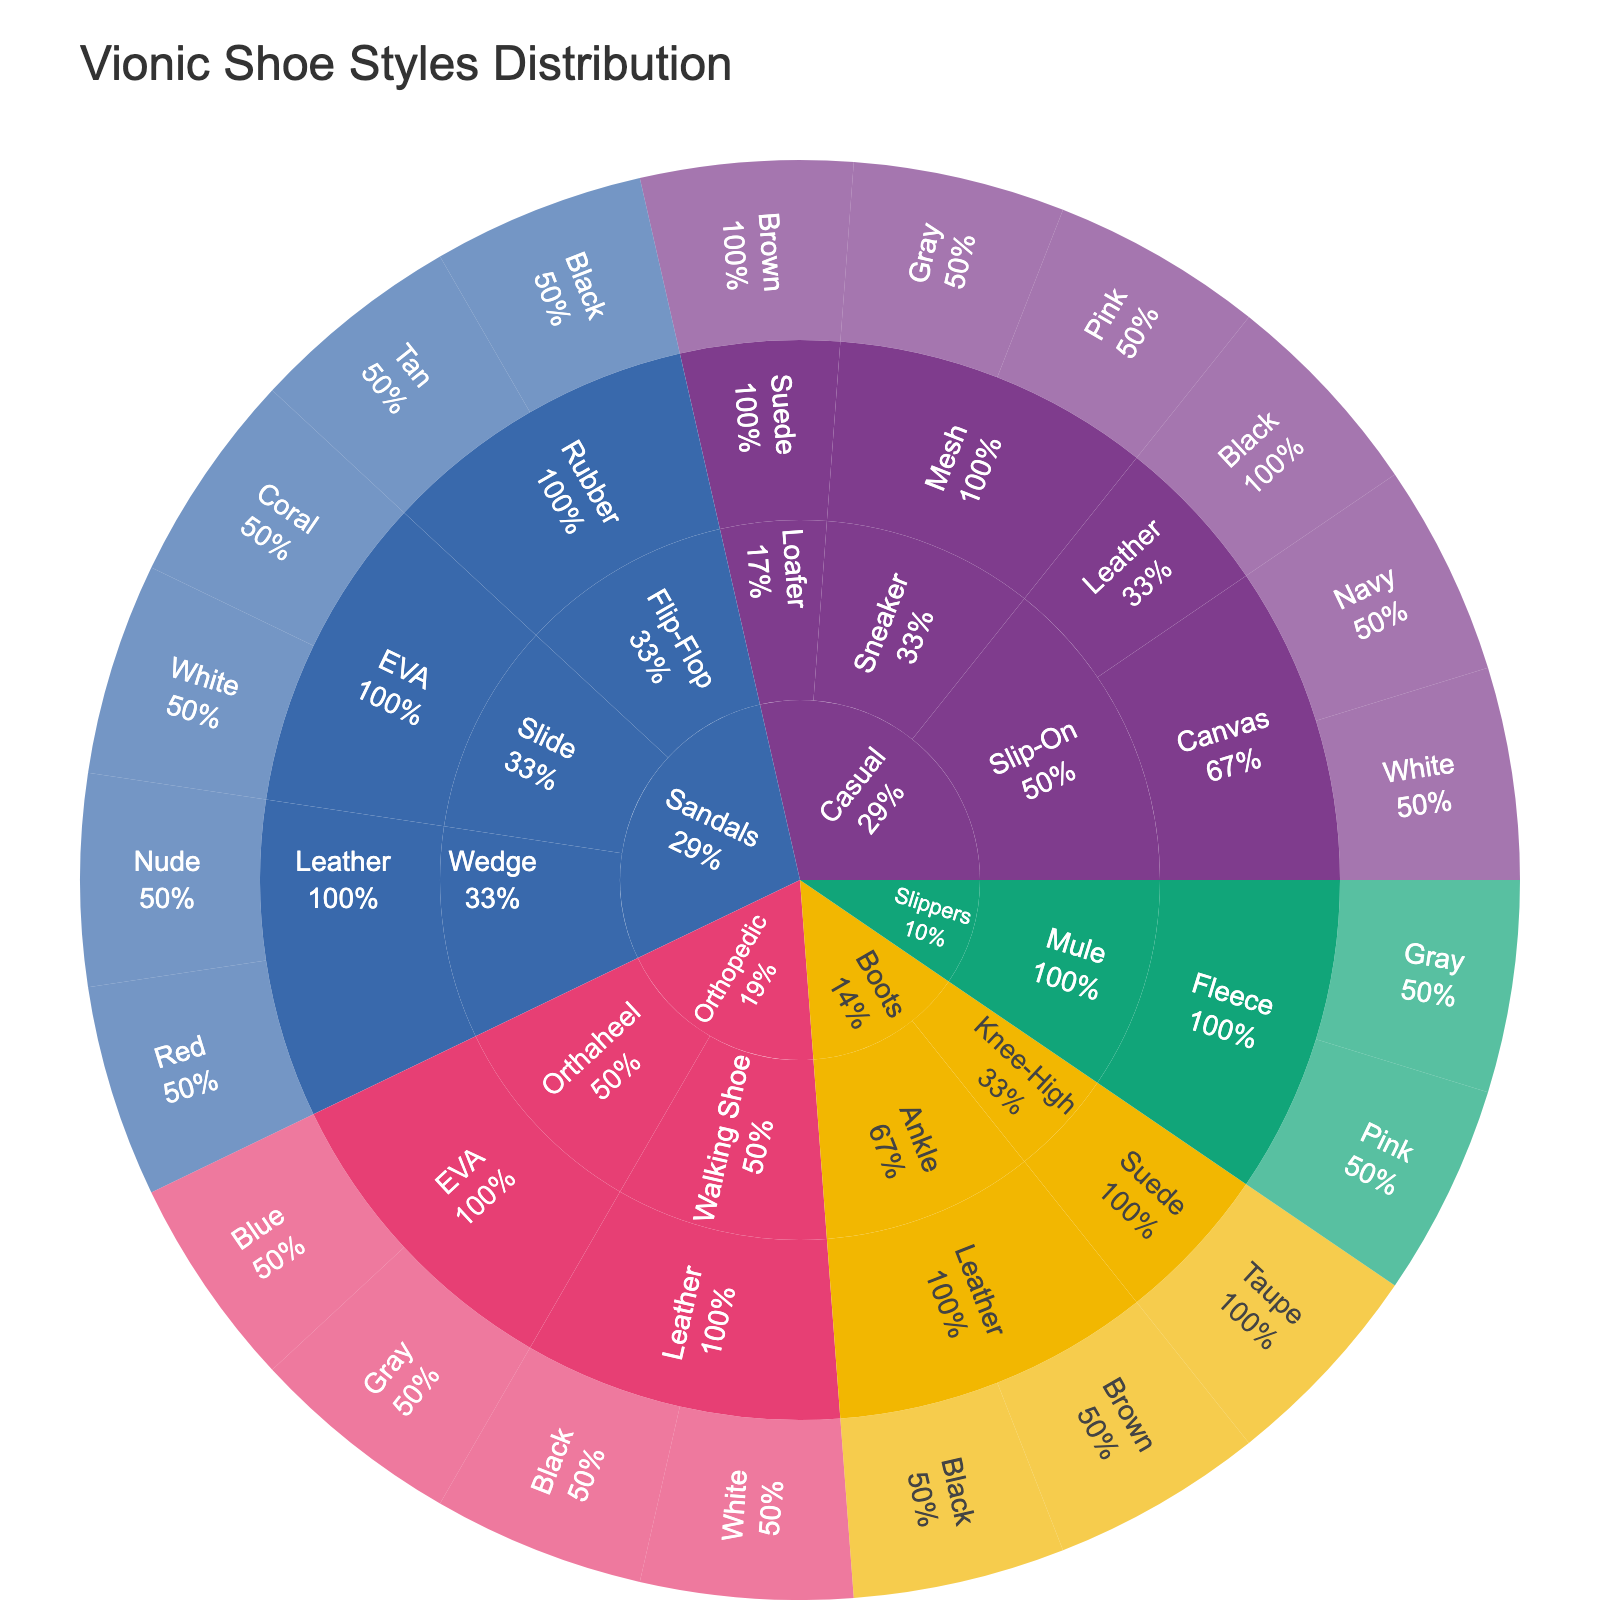What's the title of the plot? The title of the plot is usually placed at the top center of the chart. Look for the largest text which provides an overview of what the plot represents.
Answer: Vionic Shoe Styles Distribution What category has the highest number of styles? You need to identify the category with the largest proportion of the sunburst plot. Count the sectors within each category and compare them.
Answer: Casual How many color options are available for Flip-Flop sandals? Find the "Sandals" category, then the "Flip-Flop" style, and count the segments representing different colors.
Answer: 2 Which material is used for both Casual Slip-On shoes and Sandals Slide shoes? Locate each category and style on the sunburst plot, then check the material used for each and see if they'll match.
Answer: EVA Which has more variations in color, Orthopedic Walking Shoes or Sandals Wedge Shoes? Navigate to both the Orthopedic and Sandals categories, then within the respective styles, count the colors available. Compare the numbers.
Answer: Sandals Wedge Shoes How many total shoe colors are available in the Orthopedic category? Sum the number of color segments under the Orthopedic category by identifying each color for different styles.
Answer: 4 Which style in the Boots category offers the most colors? Within the Boots category, determine which style has the longest branches, each branch representing a different color.
Answer: Ankle Are there more Canvas Slip-On shoes or Mesh Sneakers in the Casual category? Within the Casual category, compare the number of color segments under Canvas Slip-On and Mesh Sneakers styles to see which has more.
Answer: Mesh Sneakers Which material is unique to Slippers? Locate the Slippers category and identify the material listed under it, then check other categories to see if this material is used anywhere else.
Answer: Fleece Do Slide Sandals come in more colors compared to Mule Slippers? Check the Sandals category for Slides, count the color options available, and repeat for the Mule style under Slippers. Compare the numbers.
Answer: No 